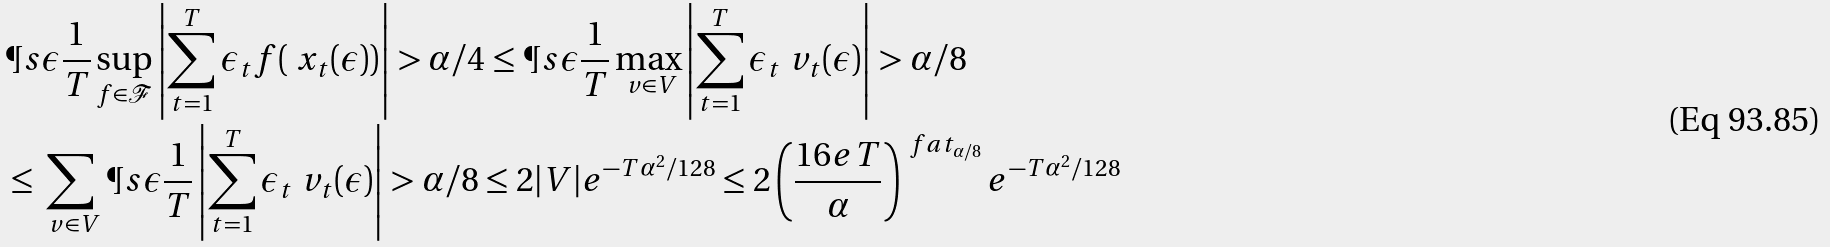Convert formula to latex. <formula><loc_0><loc_0><loc_500><loc_500>& \P s { \epsilon } { \frac { 1 } { T } \sup _ { f \in \mathcal { F } } \left | \sum _ { t = 1 } ^ { T } \epsilon _ { t } f ( \ x _ { t } ( \epsilon ) ) \right | > \alpha / 4 } \leq \P s { \epsilon } { \frac { 1 } { T } \max _ { \ v \in V } \left | \sum _ { t = 1 } ^ { T } \epsilon _ { t } \ v _ { t } ( \epsilon ) \right | > \alpha / 8 } \\ & \leq \sum _ { \ v \in V } \P s { \epsilon } { \frac { 1 } { T } \left | \sum _ { t = 1 } ^ { T } \epsilon _ { t } \ v _ { t } ( \epsilon ) \right | > \alpha / 8 } \leq 2 | V | e ^ { - T \alpha ^ { 2 } / 1 2 8 } \leq 2 \left ( \frac { 1 6 e T } { \alpha } \right ) ^ { \ f a t _ { \alpha / 8 } } e ^ { - T \alpha ^ { 2 } / 1 2 8 }</formula> 